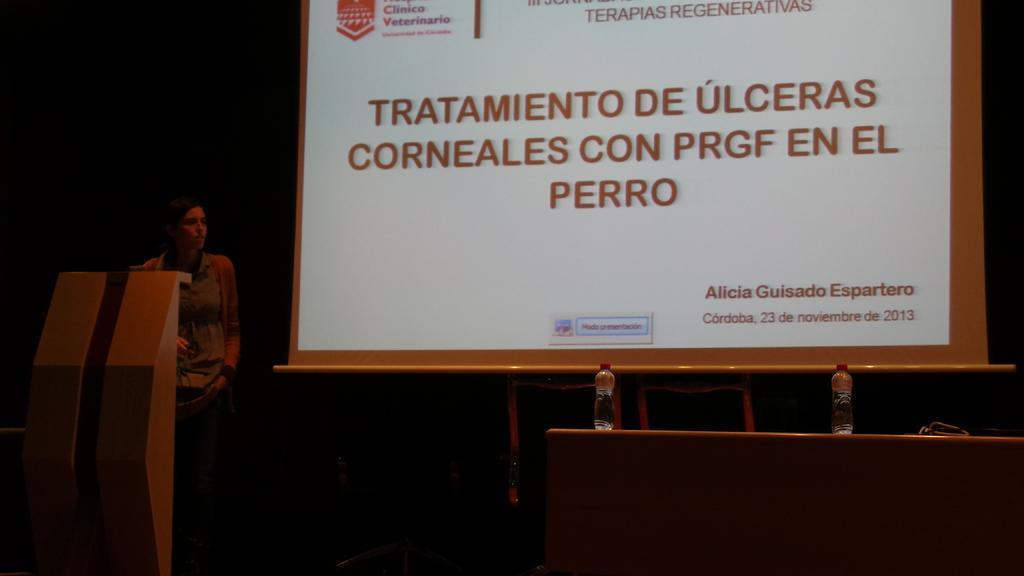How would you summarize this image in a sentence or two? In this image there is a person standing in front of the podium, beside the person there are chairs and tables, on the table there are bottles of water and some objects, behind the chairs there is a screen. 